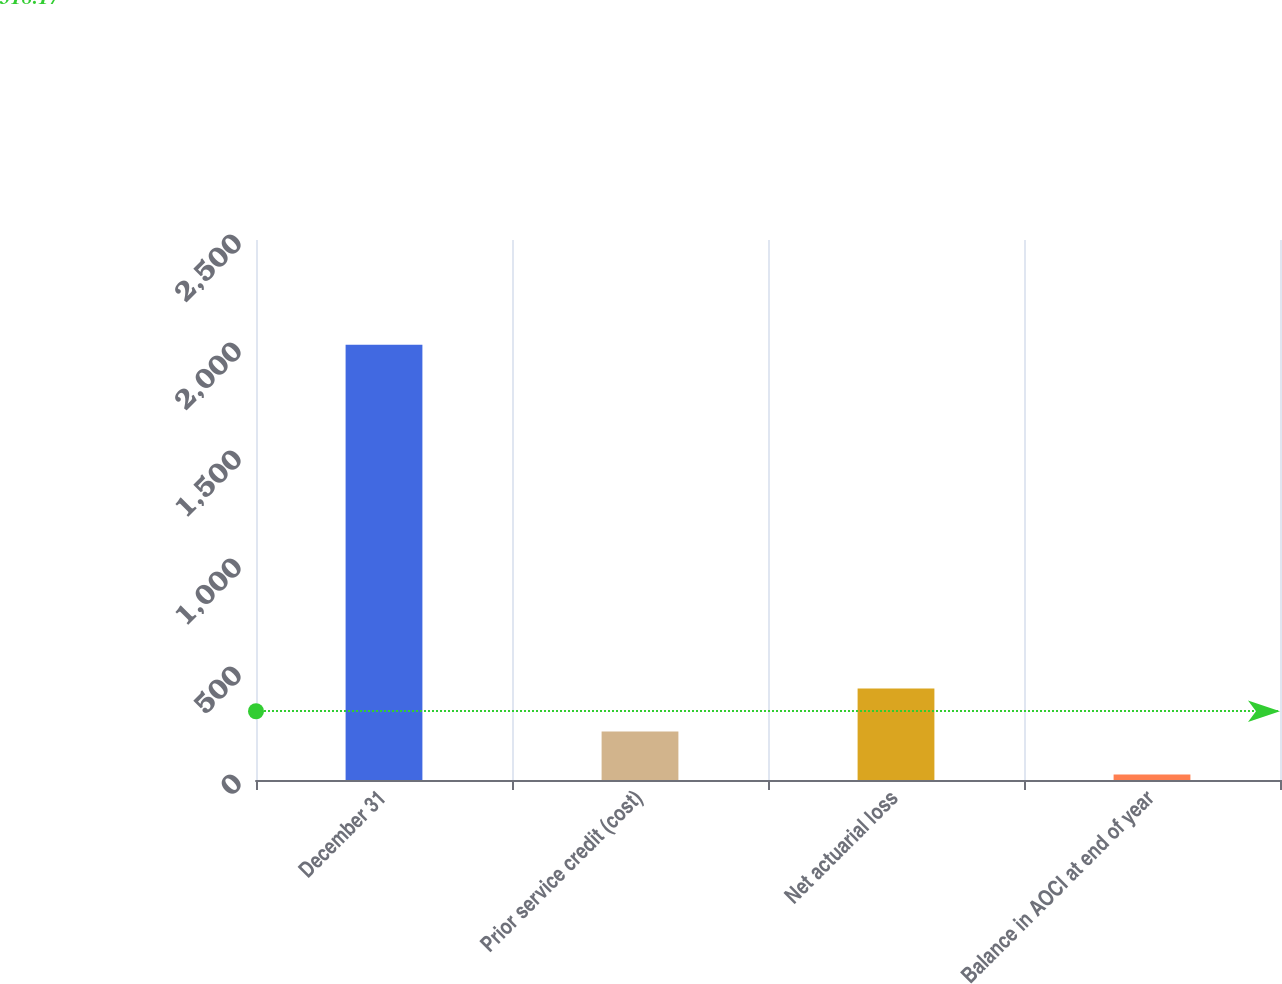Convert chart. <chart><loc_0><loc_0><loc_500><loc_500><bar_chart><fcel>December 31<fcel>Prior service credit (cost)<fcel>Net actuarial loss<fcel>Balance in AOCI at end of year<nl><fcel>2015<fcel>224.9<fcel>423.8<fcel>26<nl></chart> 